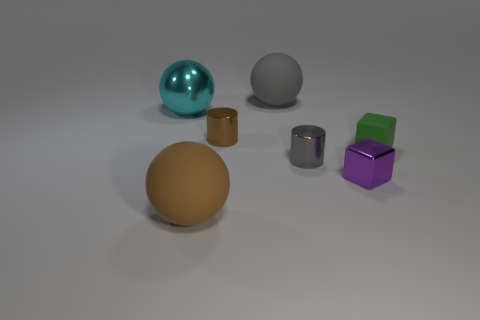The other metallic thing that is the same shape as the tiny brown metallic thing is what size?
Keep it short and to the point. Small. What is the material of the tiny gray cylinder?
Ensure brevity in your answer.  Metal. The cylinder left of the cylinder that is on the right side of the gray rubber thing to the right of the metallic sphere is made of what material?
Ensure brevity in your answer.  Metal. Is the size of the brown thing to the right of the brown matte thing the same as the gray thing to the right of the large gray sphere?
Your answer should be very brief. Yes. How many other things are the same material as the purple cube?
Offer a very short reply. 3. How many matte objects are either purple blocks or cyan balls?
Offer a very short reply. 0. Is the number of matte cubes less than the number of matte balls?
Provide a succinct answer. Yes. There is a green object; is its size the same as the brown rubber ball left of the gray metallic thing?
Your answer should be compact. No. Is there anything else that is the same shape as the tiny matte object?
Provide a short and direct response. Yes. What is the size of the gray rubber ball?
Your response must be concise. Large. 